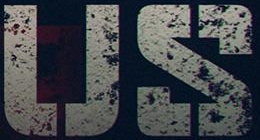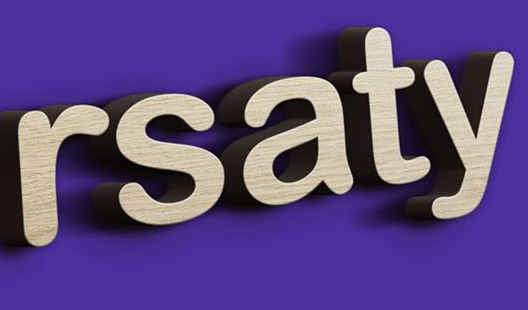What words can you see in these images in sequence, separated by a semicolon? US; rsaty 